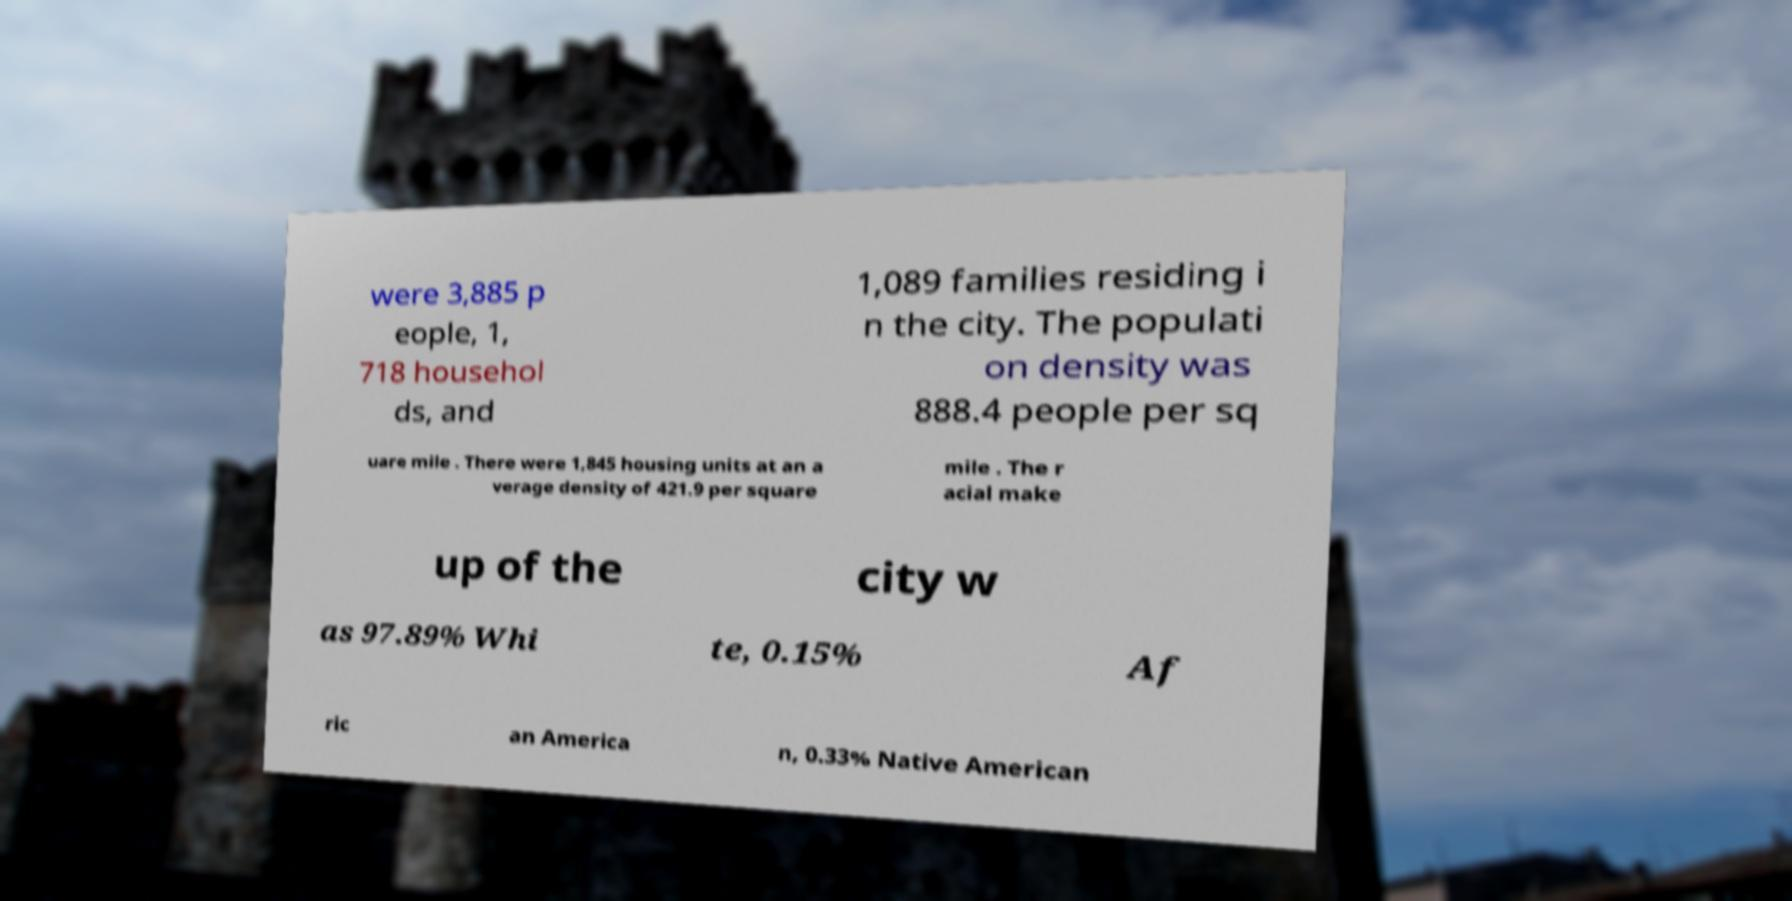Could you extract and type out the text from this image? were 3,885 p eople, 1, 718 househol ds, and 1,089 families residing i n the city. The populati on density was 888.4 people per sq uare mile . There were 1,845 housing units at an a verage density of 421.9 per square mile . The r acial make up of the city w as 97.89% Whi te, 0.15% Af ric an America n, 0.33% Native American 